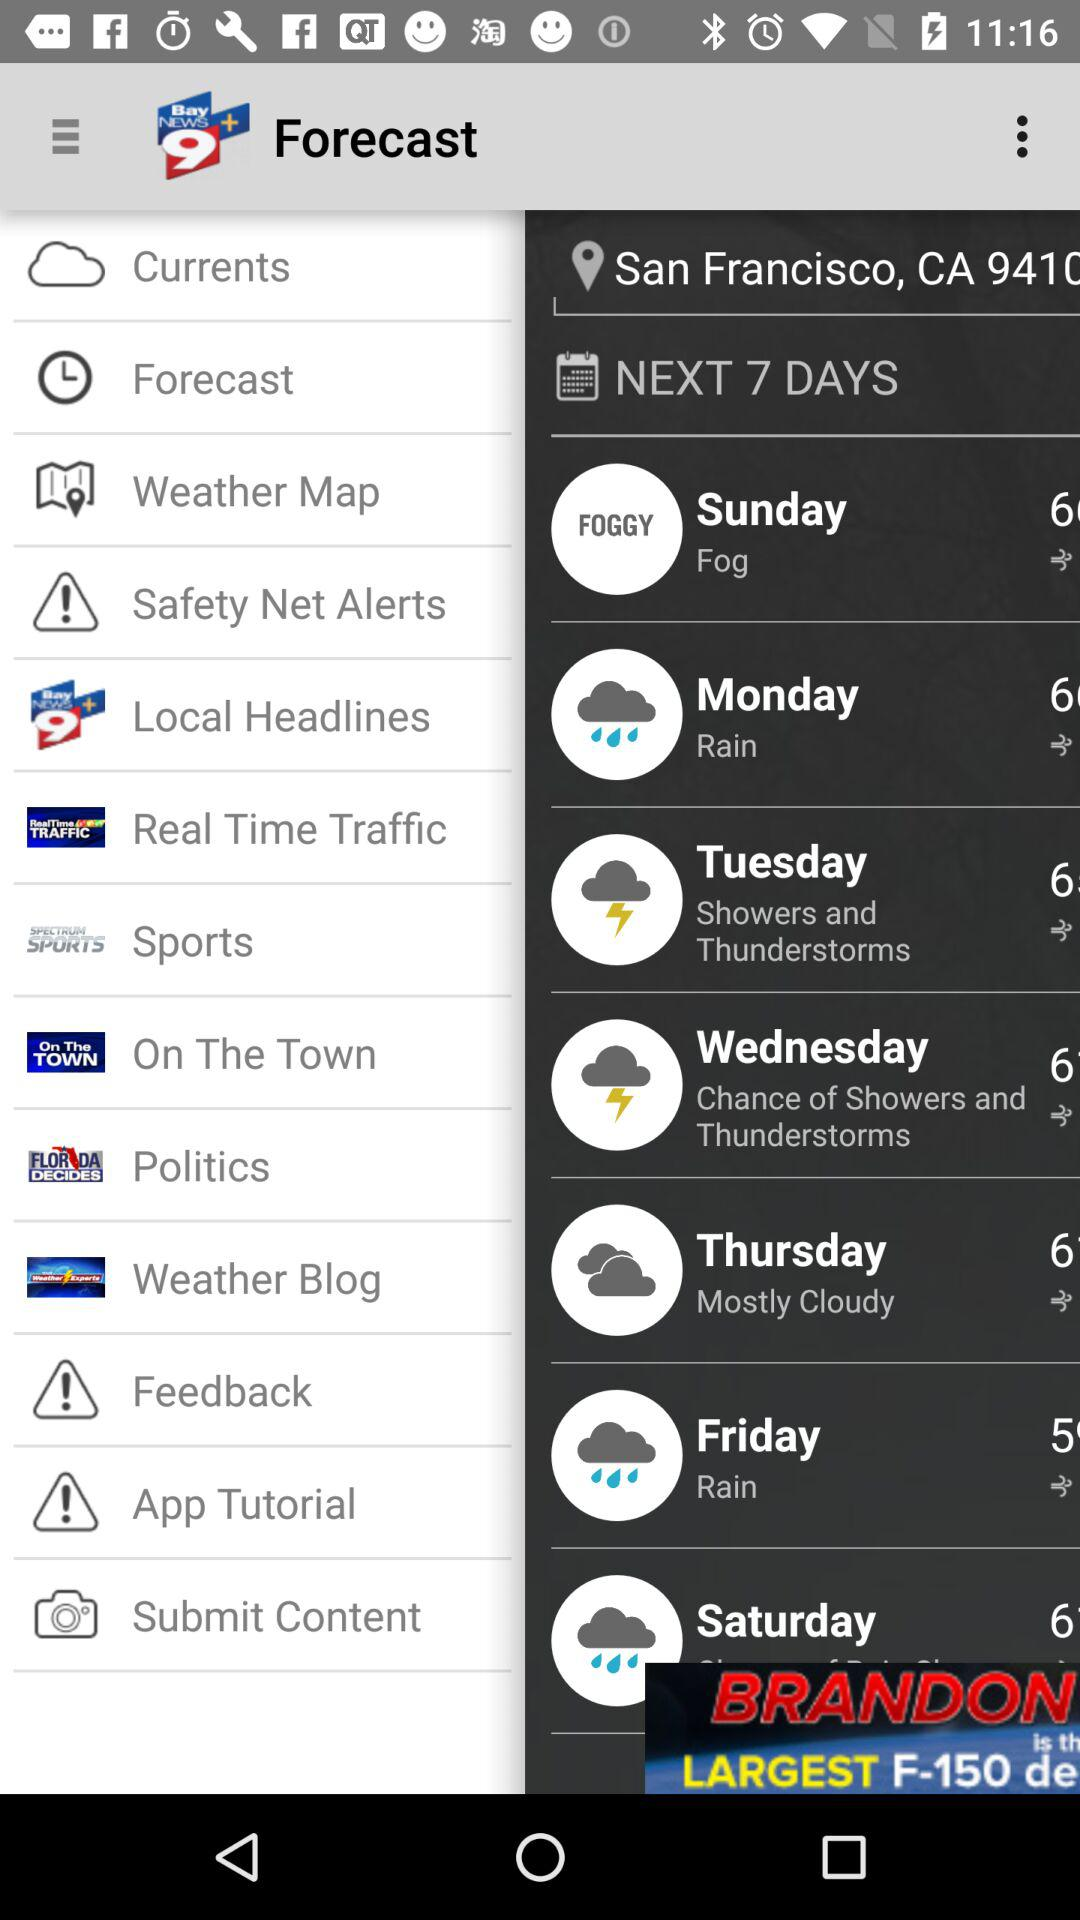How's the weather on Sunday? The weather on Sunday is foggy. 